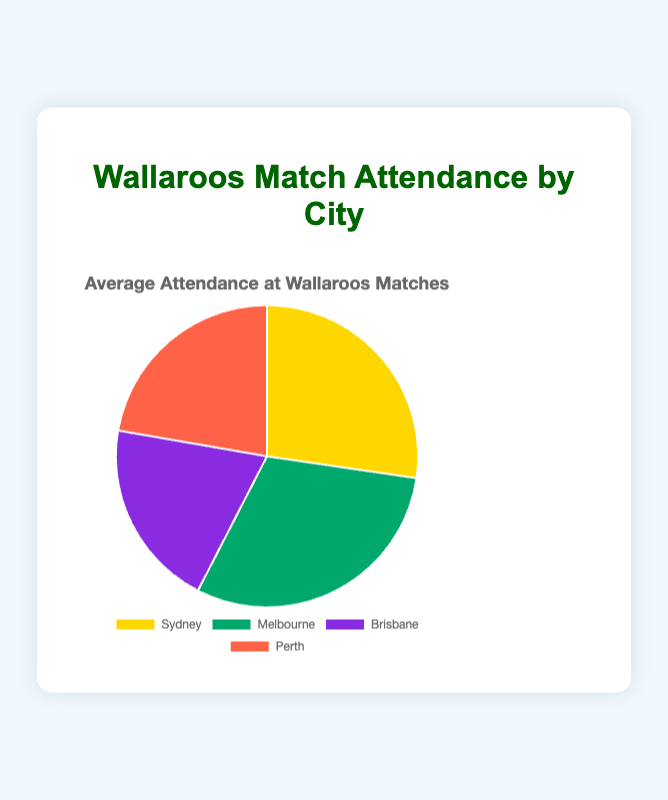What is the city with the highest average attendance at Wallaroos matches? From the pie chart, identify the city with the largest segment. Melbourne has an attendance value of 7200, which is the largest.
Answer: Melbourne What is the combined average attendance for Sydney and Brisbane? Add the attendance values of Sydney (6500) and Brisbane (4800): 6500 + 4800 = 11300.
Answer: 11300 Which city has the smallest average attendance? Identify the smallest segment on the pie chart. Brisbane's attendance value is 4800, which is the smallest.
Answer: Brisbane What is the difference in average attendance between Melbourne and Perth? Subtract the attendance of Perth (5300) from Melbourne (7200): 7200 - 5300 = 1900.
Answer: 1900 What percentage of the total average attendance does Sydney represent? First, calculate the total attendance: 6500 + 7200 + 4800 + 5300 = 23800. Then, find Sydney's percentage: (6500 / 23800) × 100 ≈ 27.31%.
Answer: ~27.31% Which segment of the pie chart is colored yellow? Identify the color associated with each city. Sydney is represented by the yellow segment.
Answer: Sydney If the total average attendance across all cities is represented as 100%, what percentage does Brisbane contribute? Calculate the total attendance: 6500 + 7200 + 4800 + 5300 = 23800. Then, find Brisbane's percentage: (4800 / 23800) × 100 ≈ 20.17%.
Answer: ~20.17% Which city has an average attendance greater than Perth but less than Melbourne? Compare the attendance values between the cities. Sydney has 6500, which is more than Perth's 5300 but less than Melbourne's 7200.
Answer: Sydney What is the mean average attendance across all four cities? Calculate the total attendance: 6500 + 7200 + 4800 + 5300 = 23800. Then, divide by the number of cities, which is 4: 23800 / 4 = 5950.
Answer: 5950 How much more is the average attendance in Melbourne compared to Sydney's? Subtract Sydney's attendance (6500) from Melbourne's (7200): 7200 - 6500 = 700.
Answer: 700 